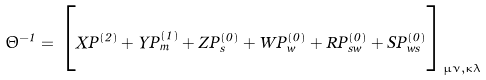<formula> <loc_0><loc_0><loc_500><loc_500>\Theta ^ { - 1 } = \Big { [ } X P ^ { ( 2 ) } + Y P _ { m } ^ { ( 1 ) } + Z P _ { s } ^ { ( 0 ) } + W P _ { w } ^ { ( 0 ) } + R P _ { s w } ^ { ( 0 ) } + S P _ { w s } ^ { ( 0 ) } \Big { ] } _ { \mu \nu , \kappa \lambda }</formula> 